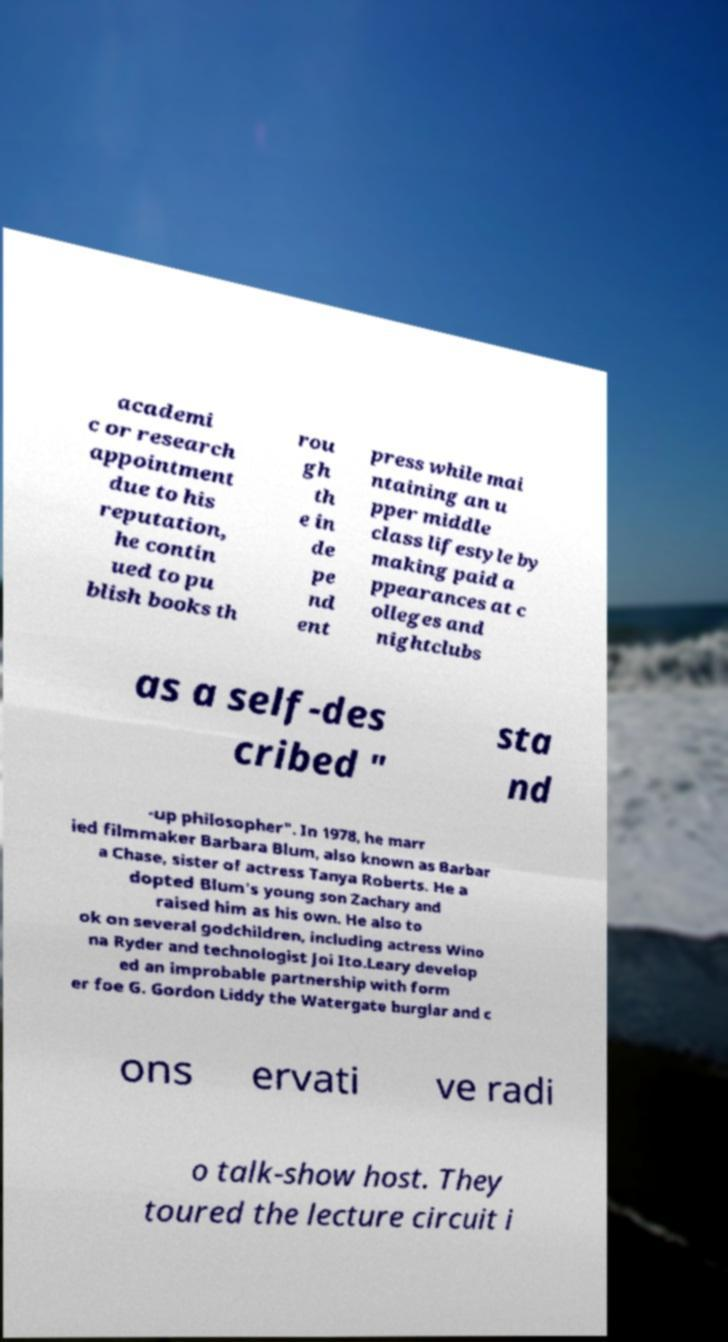Can you accurately transcribe the text from the provided image for me? academi c or research appointment due to his reputation, he contin ued to pu blish books th rou gh th e in de pe nd ent press while mai ntaining an u pper middle class lifestyle by making paid a ppearances at c olleges and nightclubs as a self-des cribed " sta nd -up philosopher". In 1978, he marr ied filmmaker Barbara Blum, also known as Barbar a Chase, sister of actress Tanya Roberts. He a dopted Blum's young son Zachary and raised him as his own. He also to ok on several godchildren, including actress Wino na Ryder and technologist Joi Ito.Leary develop ed an improbable partnership with form er foe G. Gordon Liddy the Watergate burglar and c ons ervati ve radi o talk-show host. They toured the lecture circuit i 